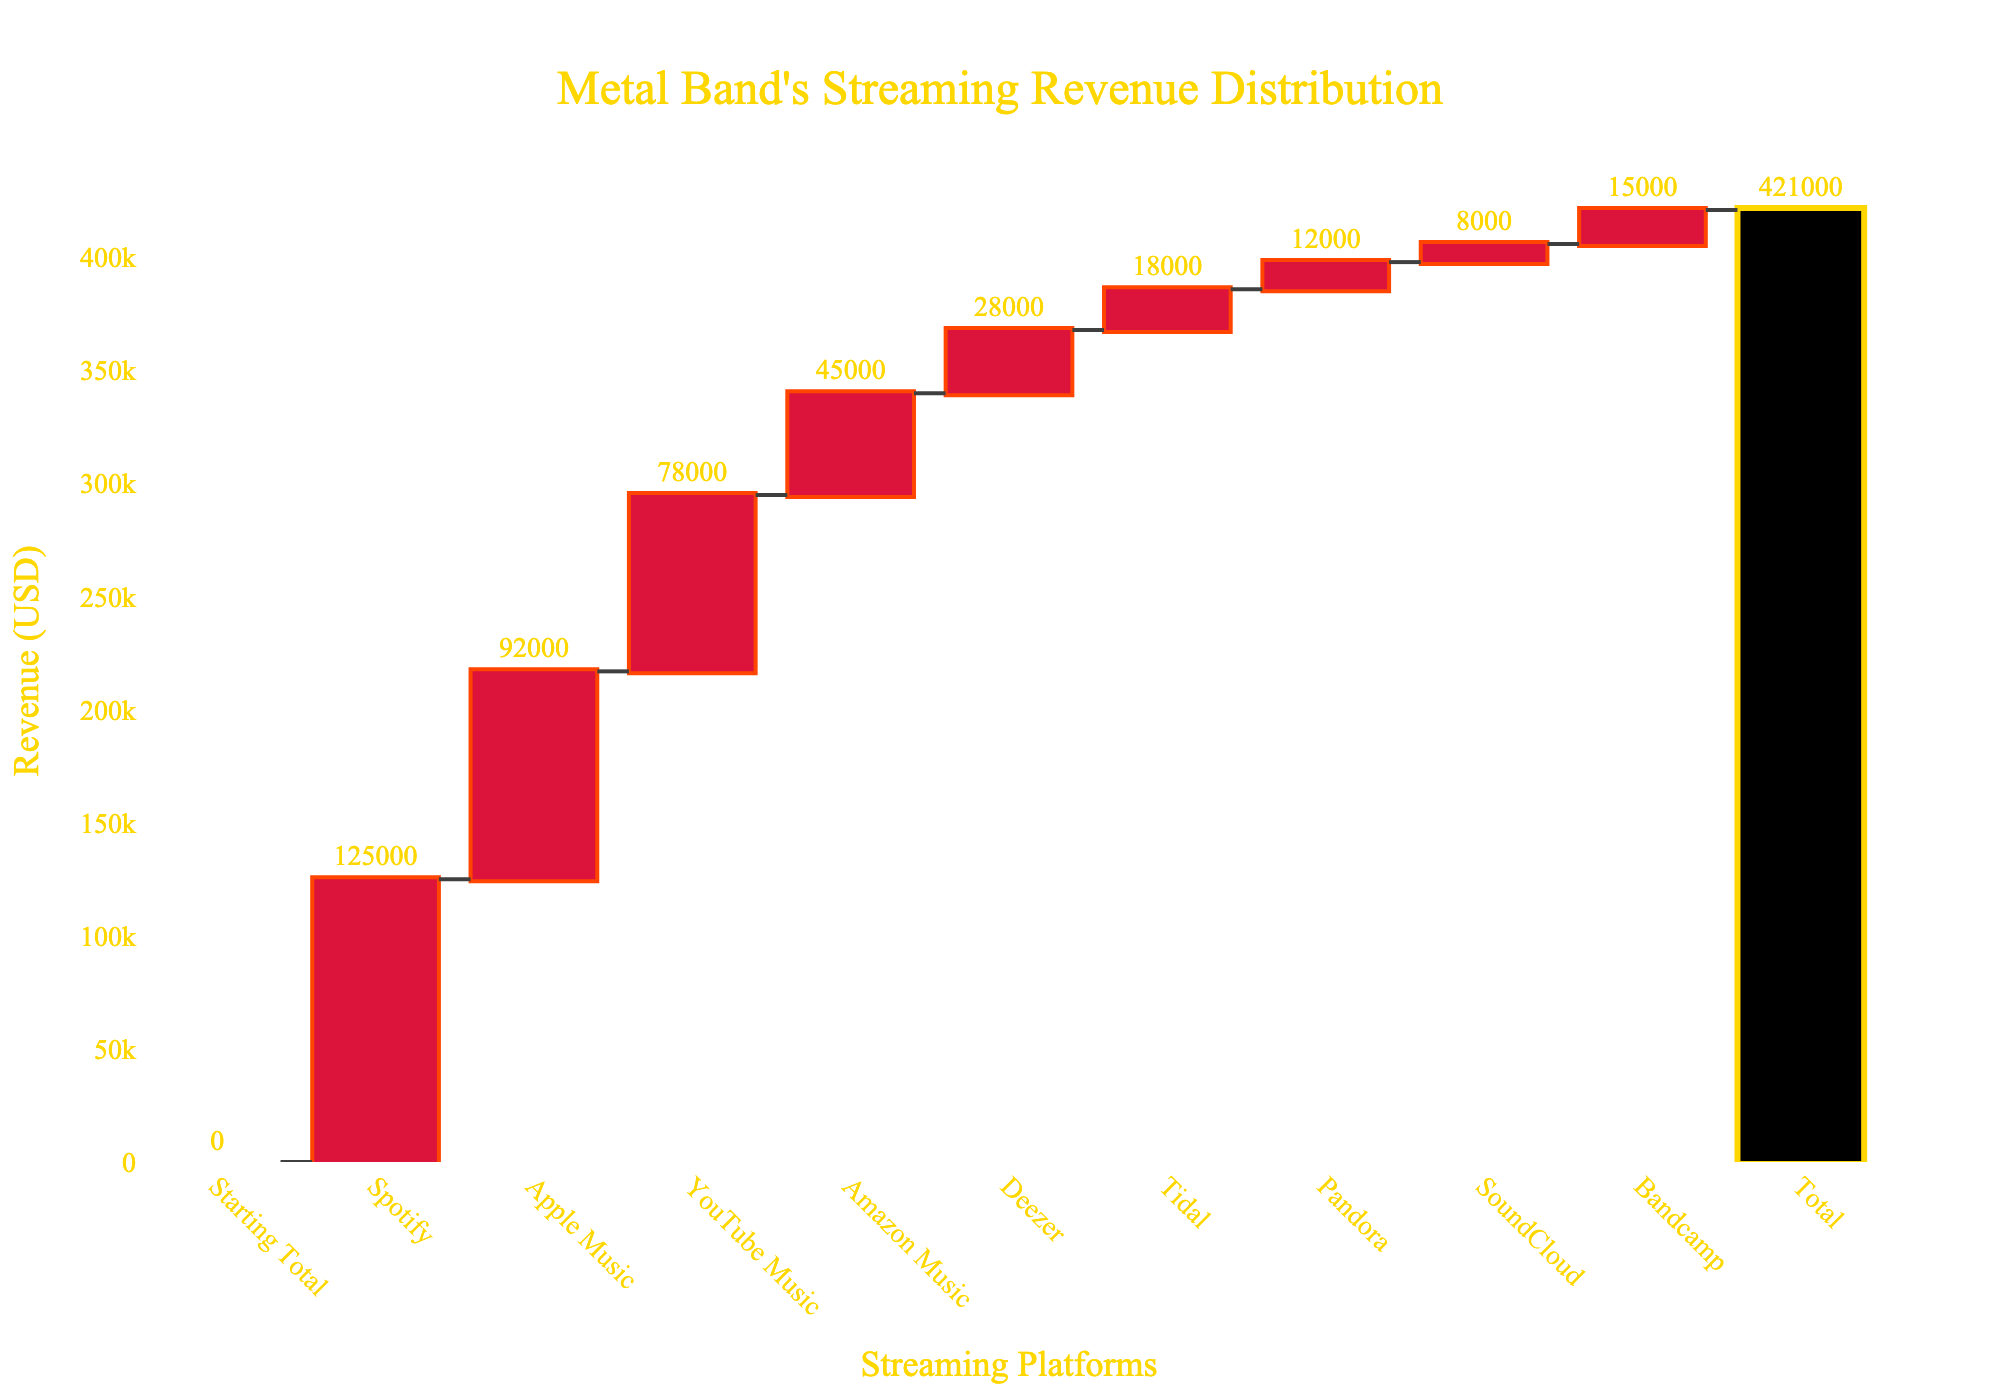What is the total revenue from streaming platforms for the metal band? According to the figure, the total revenue is noted as the last bar, which is labeled "Total" and positioned at the top of the histogram. The value is depicted just above this bar, indicating the cumulative total of all streaming platform revenues.
Answer: 421000 Which streaming platform generated the highest revenue for the band? By inspecting the heights of the bars representing each platform, the tallest bar corresponds to Spotify. The diagram presents the revenue values directly above each bar, showing the highest value for Spotify.
Answer: Spotify How much revenue was generated from YouTube Music? Within the figure, locate the bar labeled "YouTube Music." The value positioned above this bar indicates the revenue for this platform, which is stated as 78000.
Answer: 78000 What is the combined revenue from Apple Music and Amazon Music? To determine the combined revenue, find the bars for Apple Music (92000) and Amazon Music (45000). Summing these values, we have 92000 + 45000 = 137000.
Answer: 137000 Which platform contributed the least to the band's revenue, and what is the amount? Among all the labeled bars, the smallest bar represents the platform with the least revenue. The figure indicates SoundCloud as the shortest bar, with a value of 8000.
Answer: SoundCloud, 8000 By how much does Spotify's revenue surpass Deezer's? To find the difference between Spotify and Deezer, locate their revenues as indicated above their respective bars. For Spotify, it is 125000, and for Deezer, it is 28000. Subtracting these, 125000 - 28000 = 97000.
Answer: 97000 How does revenue from Tidal compare with that from Pandora? Comparing the heights and labels of the bars for Tidal and Pandora, Tidal has a revenue of 18000, and Pandora has 12000. Tidal's revenue is greater.
Answer: Tidal's revenue is greater What proportion of the total revenue comes from Bandcamp? Bandcamp's revenue can be found directly above its bar, listed as 15000. To find the proportion, divide Bandcamp's revenue by the total revenue and multiply by 100 to get a percentage: (15000 / 421000) * 100 ≈ 3.56%.
Answer: Approximately 3.56% How much more revenue did Apple Music generate than YouTube Music? According to the bars, Apple Music's revenue is 92000 and YouTube Music's is 78000. The difference is found by subtracting these: 92000 - 78000 = 14000.
Answer: 14000 What are the first and last platforms listed in the chart? Looking at the x-axis labels, the first platform listed is "Spotify," and the last platform before the "Total" bar is "Bandcamp."
Answer: Spotify and Bandcamp 